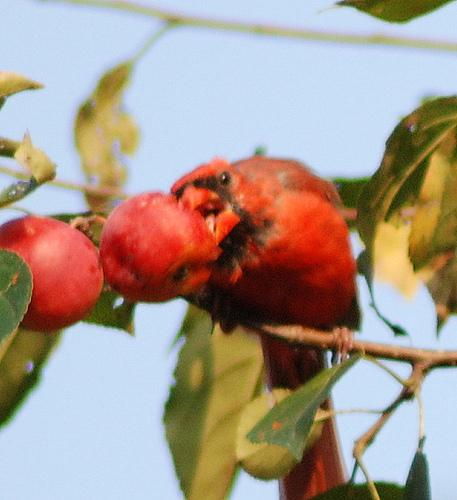Provide a concise narration of what you see in the image. A red and black bird sits on a branch, eating fruit amidst green leaves and two red berries. Explain the interaction between the main subject and its environment in the image. The bird is engaged with its surroundings, sitting on a tree branch, and feeding on a red fruit. Describe the most noticeable characteristics of the primary subject in the image. The eye-catching bird features brilliant red and black colors, a distinct beak, and long tail feathers. Mention the main subject and its distinct features in the image. The image features a red bird with black markings, long tail feathers, a red beak, and a pink tongue, perched on a tree branch and eating a fruit. Mention the central figure in the image and how it is positioned in relation to the background elements. A multi-colored bird, prominently perched on a branch, finds itself surrounded by green leaves and red fruits. Explain the primary action taking place in the image and the setting where it occurs. A bird, boasting vivid red hues and black markings, is feasting on a fruit while perched atop a tree branch laden with foliage. Imagine you're describing the image to a friend; what details stand out to you the most? You should see this picture! There's a stunning red bird with a black face sitting on a branch and eating a fruit, surrounded by green leaves with holes in them! Provide a brief overview of the primary subject and its current activity in the image. A red bird with a black marking on its face is perched on a tree branch, eating a fruit. In a poetic manner, describe the scene captured in the image. A crimson avian adorned with ebony, feasting upon fruit amidst nature's verdant embrace. In a casual tone, describe what's happening in the image. Hey, there's this cool bird with a mix of red and black on it, just chillin' on a branch and munchin' on some fruit! 